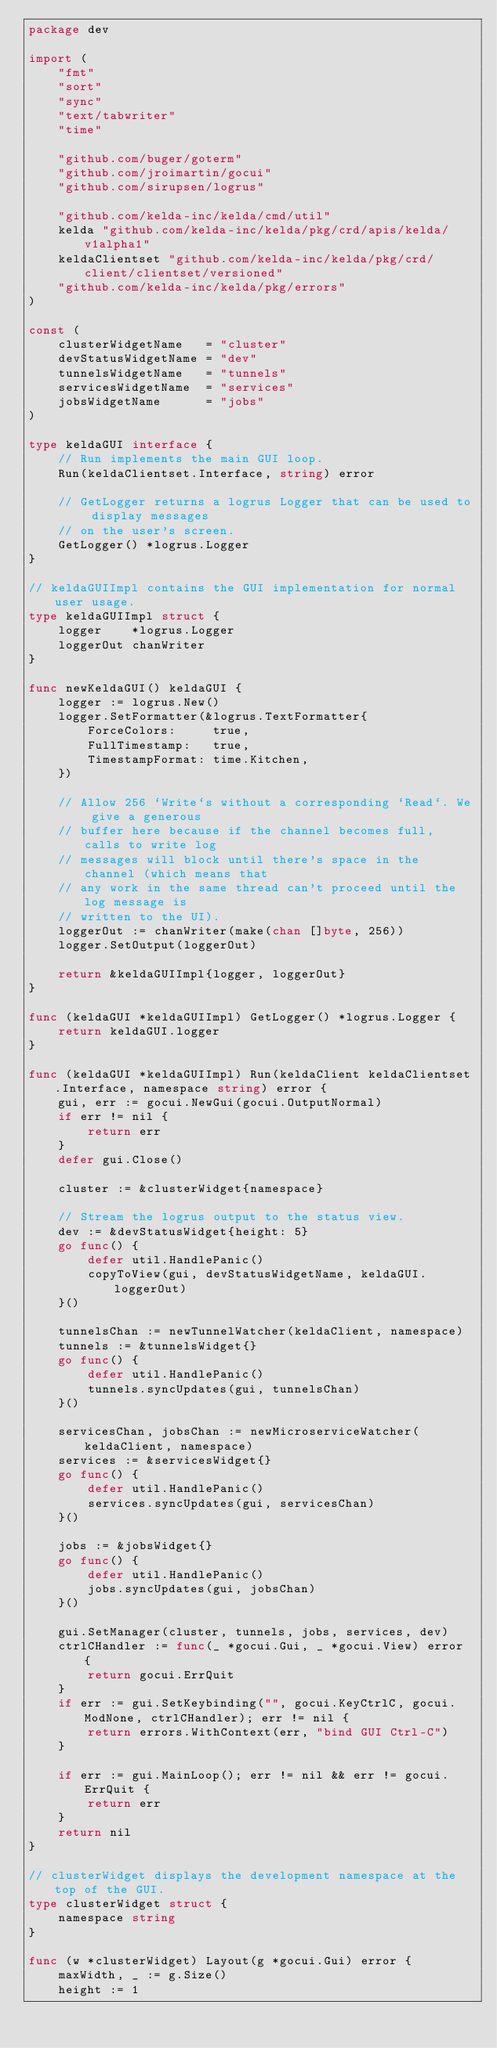Convert code to text. <code><loc_0><loc_0><loc_500><loc_500><_Go_>package dev

import (
	"fmt"
	"sort"
	"sync"
	"text/tabwriter"
	"time"

	"github.com/buger/goterm"
	"github.com/jroimartin/gocui"
	"github.com/sirupsen/logrus"

	"github.com/kelda-inc/kelda/cmd/util"
	kelda "github.com/kelda-inc/kelda/pkg/crd/apis/kelda/v1alpha1"
	keldaClientset "github.com/kelda-inc/kelda/pkg/crd/client/clientset/versioned"
	"github.com/kelda-inc/kelda/pkg/errors"
)

const (
	clusterWidgetName   = "cluster"
	devStatusWidgetName = "dev"
	tunnelsWidgetName   = "tunnels"
	servicesWidgetName  = "services"
	jobsWidgetName      = "jobs"
)

type keldaGUI interface {
	// Run implements the main GUI loop.
	Run(keldaClientset.Interface, string) error

	// GetLogger returns a logrus Logger that can be used to display messages
	// on the user's screen.
	GetLogger() *logrus.Logger
}

// keldaGUIImpl contains the GUI implementation for normal user usage.
type keldaGUIImpl struct {
	logger    *logrus.Logger
	loggerOut chanWriter
}

func newKeldaGUI() keldaGUI {
	logger := logrus.New()
	logger.SetFormatter(&logrus.TextFormatter{
		ForceColors:     true,
		FullTimestamp:   true,
		TimestampFormat: time.Kitchen,
	})

	// Allow 256 `Write`s without a corresponding `Read`. We give a generous
	// buffer here because if the channel becomes full, calls to write log
	// messages will block until there's space in the channel (which means that
	// any work in the same thread can't proceed until the log message is
	// written to the UI).
	loggerOut := chanWriter(make(chan []byte, 256))
	logger.SetOutput(loggerOut)

	return &keldaGUIImpl{logger, loggerOut}
}

func (keldaGUI *keldaGUIImpl) GetLogger() *logrus.Logger {
	return keldaGUI.logger
}

func (keldaGUI *keldaGUIImpl) Run(keldaClient keldaClientset.Interface, namespace string) error {
	gui, err := gocui.NewGui(gocui.OutputNormal)
	if err != nil {
		return err
	}
	defer gui.Close()

	cluster := &clusterWidget{namespace}

	// Stream the logrus output to the status view.
	dev := &devStatusWidget{height: 5}
	go func() {
		defer util.HandlePanic()
		copyToView(gui, devStatusWidgetName, keldaGUI.loggerOut)
	}()

	tunnelsChan := newTunnelWatcher(keldaClient, namespace)
	tunnels := &tunnelsWidget{}
	go func() {
		defer util.HandlePanic()
		tunnels.syncUpdates(gui, tunnelsChan)
	}()

	servicesChan, jobsChan := newMicroserviceWatcher(keldaClient, namespace)
	services := &servicesWidget{}
	go func() {
		defer util.HandlePanic()
		services.syncUpdates(gui, servicesChan)
	}()

	jobs := &jobsWidget{}
	go func() {
		defer util.HandlePanic()
		jobs.syncUpdates(gui, jobsChan)
	}()

	gui.SetManager(cluster, tunnels, jobs, services, dev)
	ctrlCHandler := func(_ *gocui.Gui, _ *gocui.View) error {
		return gocui.ErrQuit
	}
	if err := gui.SetKeybinding("", gocui.KeyCtrlC, gocui.ModNone, ctrlCHandler); err != nil {
		return errors.WithContext(err, "bind GUI Ctrl-C")
	}

	if err := gui.MainLoop(); err != nil && err != gocui.ErrQuit {
		return err
	}
	return nil
}

// clusterWidget displays the development namespace at the top of the GUI.
type clusterWidget struct {
	namespace string
}

func (w *clusterWidget) Layout(g *gocui.Gui) error {
	maxWidth, _ := g.Size()
	height := 1
</code> 